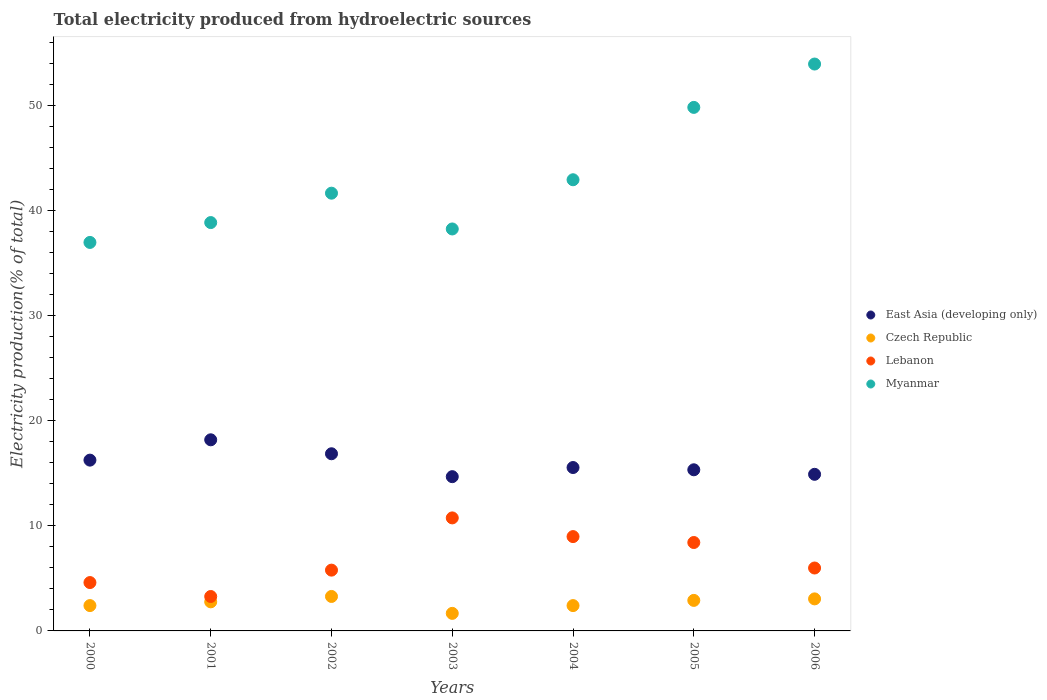What is the total electricity produced in Czech Republic in 2003?
Ensure brevity in your answer.  1.67. Across all years, what is the maximum total electricity produced in Lebanon?
Keep it short and to the point. 10.75. Across all years, what is the minimum total electricity produced in Lebanon?
Offer a very short reply. 3.28. In which year was the total electricity produced in Czech Republic maximum?
Your response must be concise. 2002. In which year was the total electricity produced in Czech Republic minimum?
Offer a very short reply. 2003. What is the total total electricity produced in Czech Republic in the graph?
Your answer should be compact. 18.49. What is the difference between the total electricity produced in Lebanon in 2001 and that in 2003?
Your answer should be compact. -7.48. What is the difference between the total electricity produced in Czech Republic in 2005 and the total electricity produced in Myanmar in 2000?
Offer a very short reply. -34.06. What is the average total electricity produced in Lebanon per year?
Ensure brevity in your answer.  6.83. In the year 2003, what is the difference between the total electricity produced in Czech Republic and total electricity produced in Lebanon?
Provide a short and direct response. -9.08. What is the ratio of the total electricity produced in Myanmar in 2003 to that in 2005?
Offer a very short reply. 0.77. What is the difference between the highest and the second highest total electricity produced in East Asia (developing only)?
Your answer should be very brief. 1.33. What is the difference between the highest and the lowest total electricity produced in Myanmar?
Your answer should be very brief. 16.97. In how many years, is the total electricity produced in Myanmar greater than the average total electricity produced in Myanmar taken over all years?
Make the answer very short. 2. Is it the case that in every year, the sum of the total electricity produced in Lebanon and total electricity produced in East Asia (developing only)  is greater than the sum of total electricity produced in Myanmar and total electricity produced in Czech Republic?
Make the answer very short. Yes. Does the total electricity produced in East Asia (developing only) monotonically increase over the years?
Provide a succinct answer. No. How many years are there in the graph?
Your answer should be compact. 7. Are the values on the major ticks of Y-axis written in scientific E-notation?
Offer a terse response. No. Does the graph contain any zero values?
Your answer should be compact. No. Where does the legend appear in the graph?
Keep it short and to the point. Center right. How are the legend labels stacked?
Your answer should be very brief. Vertical. What is the title of the graph?
Offer a very short reply. Total electricity produced from hydroelectric sources. What is the label or title of the Y-axis?
Your answer should be compact. Electricity production(% of total). What is the Electricity production(% of total) of East Asia (developing only) in 2000?
Keep it short and to the point. 16.25. What is the Electricity production(% of total) of Czech Republic in 2000?
Ensure brevity in your answer.  2.41. What is the Electricity production(% of total) of Lebanon in 2000?
Give a very brief answer. 4.6. What is the Electricity production(% of total) in Myanmar in 2000?
Keep it short and to the point. 36.97. What is the Electricity production(% of total) of East Asia (developing only) in 2001?
Provide a short and direct response. 18.19. What is the Electricity production(% of total) in Czech Republic in 2001?
Offer a terse response. 2.77. What is the Electricity production(% of total) of Lebanon in 2001?
Provide a succinct answer. 3.28. What is the Electricity production(% of total) in Myanmar in 2001?
Ensure brevity in your answer.  38.86. What is the Electricity production(% of total) of East Asia (developing only) in 2002?
Provide a succinct answer. 16.86. What is the Electricity production(% of total) of Czech Republic in 2002?
Offer a terse response. 3.28. What is the Electricity production(% of total) in Lebanon in 2002?
Your answer should be compact. 5.78. What is the Electricity production(% of total) of Myanmar in 2002?
Your answer should be compact. 41.65. What is the Electricity production(% of total) in East Asia (developing only) in 2003?
Provide a short and direct response. 14.68. What is the Electricity production(% of total) of Czech Republic in 2003?
Give a very brief answer. 1.67. What is the Electricity production(% of total) in Lebanon in 2003?
Your response must be concise. 10.75. What is the Electricity production(% of total) in Myanmar in 2003?
Your answer should be compact. 38.25. What is the Electricity production(% of total) in East Asia (developing only) in 2004?
Keep it short and to the point. 15.55. What is the Electricity production(% of total) of Czech Republic in 2004?
Keep it short and to the point. 2.41. What is the Electricity production(% of total) in Lebanon in 2004?
Provide a succinct answer. 8.98. What is the Electricity production(% of total) in Myanmar in 2004?
Offer a very short reply. 42.93. What is the Electricity production(% of total) of East Asia (developing only) in 2005?
Your response must be concise. 15.33. What is the Electricity production(% of total) of Czech Republic in 2005?
Your answer should be very brief. 2.9. What is the Electricity production(% of total) in Lebanon in 2005?
Your answer should be very brief. 8.41. What is the Electricity production(% of total) of Myanmar in 2005?
Your response must be concise. 49.82. What is the Electricity production(% of total) in East Asia (developing only) in 2006?
Offer a terse response. 14.9. What is the Electricity production(% of total) of Czech Republic in 2006?
Offer a very short reply. 3.05. What is the Electricity production(% of total) of Lebanon in 2006?
Your response must be concise. 5.99. What is the Electricity production(% of total) in Myanmar in 2006?
Your answer should be compact. 53.94. Across all years, what is the maximum Electricity production(% of total) in East Asia (developing only)?
Give a very brief answer. 18.19. Across all years, what is the maximum Electricity production(% of total) of Czech Republic?
Make the answer very short. 3.28. Across all years, what is the maximum Electricity production(% of total) of Lebanon?
Your answer should be compact. 10.75. Across all years, what is the maximum Electricity production(% of total) of Myanmar?
Keep it short and to the point. 53.94. Across all years, what is the minimum Electricity production(% of total) of East Asia (developing only)?
Offer a terse response. 14.68. Across all years, what is the minimum Electricity production(% of total) in Czech Republic?
Your answer should be very brief. 1.67. Across all years, what is the minimum Electricity production(% of total) of Lebanon?
Your answer should be compact. 3.28. Across all years, what is the minimum Electricity production(% of total) in Myanmar?
Your answer should be compact. 36.97. What is the total Electricity production(% of total) in East Asia (developing only) in the graph?
Your response must be concise. 111.76. What is the total Electricity production(% of total) in Czech Republic in the graph?
Provide a succinct answer. 18.49. What is the total Electricity production(% of total) in Lebanon in the graph?
Offer a terse response. 47.79. What is the total Electricity production(% of total) in Myanmar in the graph?
Provide a short and direct response. 302.42. What is the difference between the Electricity production(% of total) of East Asia (developing only) in 2000 and that in 2001?
Provide a short and direct response. -1.93. What is the difference between the Electricity production(% of total) of Czech Republic in 2000 and that in 2001?
Offer a very short reply. -0.36. What is the difference between the Electricity production(% of total) of Lebanon in 2000 and that in 2001?
Make the answer very short. 1.33. What is the difference between the Electricity production(% of total) in Myanmar in 2000 and that in 2001?
Make the answer very short. -1.89. What is the difference between the Electricity production(% of total) in East Asia (developing only) in 2000 and that in 2002?
Your answer should be very brief. -0.61. What is the difference between the Electricity production(% of total) in Czech Republic in 2000 and that in 2002?
Offer a terse response. -0.87. What is the difference between the Electricity production(% of total) of Lebanon in 2000 and that in 2002?
Your response must be concise. -1.18. What is the difference between the Electricity production(% of total) in Myanmar in 2000 and that in 2002?
Offer a very short reply. -4.69. What is the difference between the Electricity production(% of total) of East Asia (developing only) in 2000 and that in 2003?
Offer a very short reply. 1.57. What is the difference between the Electricity production(% of total) in Czech Republic in 2000 and that in 2003?
Offer a very short reply. 0.74. What is the difference between the Electricity production(% of total) of Lebanon in 2000 and that in 2003?
Make the answer very short. -6.15. What is the difference between the Electricity production(% of total) of Myanmar in 2000 and that in 2003?
Your response must be concise. -1.28. What is the difference between the Electricity production(% of total) in East Asia (developing only) in 2000 and that in 2004?
Offer a very short reply. 0.7. What is the difference between the Electricity production(% of total) in Czech Republic in 2000 and that in 2004?
Make the answer very short. 0. What is the difference between the Electricity production(% of total) in Lebanon in 2000 and that in 2004?
Keep it short and to the point. -4.37. What is the difference between the Electricity production(% of total) of Myanmar in 2000 and that in 2004?
Give a very brief answer. -5.96. What is the difference between the Electricity production(% of total) of East Asia (developing only) in 2000 and that in 2005?
Make the answer very short. 0.92. What is the difference between the Electricity production(% of total) in Czech Republic in 2000 and that in 2005?
Keep it short and to the point. -0.49. What is the difference between the Electricity production(% of total) of Lebanon in 2000 and that in 2005?
Ensure brevity in your answer.  -3.81. What is the difference between the Electricity production(% of total) of Myanmar in 2000 and that in 2005?
Ensure brevity in your answer.  -12.85. What is the difference between the Electricity production(% of total) in East Asia (developing only) in 2000 and that in 2006?
Your answer should be very brief. 1.35. What is the difference between the Electricity production(% of total) in Czech Republic in 2000 and that in 2006?
Offer a terse response. -0.64. What is the difference between the Electricity production(% of total) in Lebanon in 2000 and that in 2006?
Provide a succinct answer. -1.38. What is the difference between the Electricity production(% of total) of Myanmar in 2000 and that in 2006?
Provide a short and direct response. -16.97. What is the difference between the Electricity production(% of total) in East Asia (developing only) in 2001 and that in 2002?
Your response must be concise. 1.33. What is the difference between the Electricity production(% of total) of Czech Republic in 2001 and that in 2002?
Offer a very short reply. -0.51. What is the difference between the Electricity production(% of total) in Lebanon in 2001 and that in 2002?
Keep it short and to the point. -2.51. What is the difference between the Electricity production(% of total) in Myanmar in 2001 and that in 2002?
Make the answer very short. -2.8. What is the difference between the Electricity production(% of total) of East Asia (developing only) in 2001 and that in 2003?
Make the answer very short. 3.51. What is the difference between the Electricity production(% of total) in Czech Republic in 2001 and that in 2003?
Keep it short and to the point. 1.1. What is the difference between the Electricity production(% of total) of Lebanon in 2001 and that in 2003?
Ensure brevity in your answer.  -7.48. What is the difference between the Electricity production(% of total) of Myanmar in 2001 and that in 2003?
Offer a terse response. 0.61. What is the difference between the Electricity production(% of total) of East Asia (developing only) in 2001 and that in 2004?
Offer a terse response. 2.64. What is the difference between the Electricity production(% of total) of Czech Republic in 2001 and that in 2004?
Provide a short and direct response. 0.36. What is the difference between the Electricity production(% of total) of Lebanon in 2001 and that in 2004?
Keep it short and to the point. -5.7. What is the difference between the Electricity production(% of total) in Myanmar in 2001 and that in 2004?
Offer a very short reply. -4.07. What is the difference between the Electricity production(% of total) of East Asia (developing only) in 2001 and that in 2005?
Keep it short and to the point. 2.85. What is the difference between the Electricity production(% of total) of Czech Republic in 2001 and that in 2005?
Your answer should be very brief. -0.14. What is the difference between the Electricity production(% of total) of Lebanon in 2001 and that in 2005?
Offer a terse response. -5.14. What is the difference between the Electricity production(% of total) in Myanmar in 2001 and that in 2005?
Make the answer very short. -10.96. What is the difference between the Electricity production(% of total) in East Asia (developing only) in 2001 and that in 2006?
Offer a very short reply. 3.28. What is the difference between the Electricity production(% of total) of Czech Republic in 2001 and that in 2006?
Offer a terse response. -0.28. What is the difference between the Electricity production(% of total) in Lebanon in 2001 and that in 2006?
Keep it short and to the point. -2.71. What is the difference between the Electricity production(% of total) in Myanmar in 2001 and that in 2006?
Offer a very short reply. -15.09. What is the difference between the Electricity production(% of total) of East Asia (developing only) in 2002 and that in 2003?
Your answer should be very brief. 2.18. What is the difference between the Electricity production(% of total) of Czech Republic in 2002 and that in 2003?
Keep it short and to the point. 1.61. What is the difference between the Electricity production(% of total) in Lebanon in 2002 and that in 2003?
Offer a terse response. -4.97. What is the difference between the Electricity production(% of total) in Myanmar in 2002 and that in 2003?
Your answer should be compact. 3.4. What is the difference between the Electricity production(% of total) in East Asia (developing only) in 2002 and that in 2004?
Offer a very short reply. 1.31. What is the difference between the Electricity production(% of total) of Czech Republic in 2002 and that in 2004?
Ensure brevity in your answer.  0.87. What is the difference between the Electricity production(% of total) of Lebanon in 2002 and that in 2004?
Offer a terse response. -3.19. What is the difference between the Electricity production(% of total) in Myanmar in 2002 and that in 2004?
Offer a terse response. -1.28. What is the difference between the Electricity production(% of total) in East Asia (developing only) in 2002 and that in 2005?
Ensure brevity in your answer.  1.53. What is the difference between the Electricity production(% of total) in Czech Republic in 2002 and that in 2005?
Ensure brevity in your answer.  0.37. What is the difference between the Electricity production(% of total) of Lebanon in 2002 and that in 2005?
Offer a very short reply. -2.63. What is the difference between the Electricity production(% of total) of Myanmar in 2002 and that in 2005?
Provide a short and direct response. -8.16. What is the difference between the Electricity production(% of total) of East Asia (developing only) in 2002 and that in 2006?
Give a very brief answer. 1.96. What is the difference between the Electricity production(% of total) of Czech Republic in 2002 and that in 2006?
Offer a terse response. 0.23. What is the difference between the Electricity production(% of total) in Lebanon in 2002 and that in 2006?
Offer a terse response. -0.2. What is the difference between the Electricity production(% of total) in Myanmar in 2002 and that in 2006?
Your answer should be very brief. -12.29. What is the difference between the Electricity production(% of total) of East Asia (developing only) in 2003 and that in 2004?
Make the answer very short. -0.87. What is the difference between the Electricity production(% of total) of Czech Republic in 2003 and that in 2004?
Your answer should be compact. -0.74. What is the difference between the Electricity production(% of total) in Lebanon in 2003 and that in 2004?
Offer a terse response. 1.78. What is the difference between the Electricity production(% of total) in Myanmar in 2003 and that in 2004?
Your answer should be very brief. -4.68. What is the difference between the Electricity production(% of total) in East Asia (developing only) in 2003 and that in 2005?
Keep it short and to the point. -0.65. What is the difference between the Electricity production(% of total) in Czech Republic in 2003 and that in 2005?
Provide a short and direct response. -1.23. What is the difference between the Electricity production(% of total) in Lebanon in 2003 and that in 2005?
Your answer should be compact. 2.34. What is the difference between the Electricity production(% of total) in Myanmar in 2003 and that in 2005?
Offer a terse response. -11.57. What is the difference between the Electricity production(% of total) in East Asia (developing only) in 2003 and that in 2006?
Provide a succinct answer. -0.22. What is the difference between the Electricity production(% of total) of Czech Republic in 2003 and that in 2006?
Keep it short and to the point. -1.38. What is the difference between the Electricity production(% of total) in Lebanon in 2003 and that in 2006?
Provide a succinct answer. 4.77. What is the difference between the Electricity production(% of total) of Myanmar in 2003 and that in 2006?
Give a very brief answer. -15.69. What is the difference between the Electricity production(% of total) in East Asia (developing only) in 2004 and that in 2005?
Provide a succinct answer. 0.22. What is the difference between the Electricity production(% of total) in Czech Republic in 2004 and that in 2005?
Provide a succinct answer. -0.5. What is the difference between the Electricity production(% of total) of Lebanon in 2004 and that in 2005?
Give a very brief answer. 0.56. What is the difference between the Electricity production(% of total) in Myanmar in 2004 and that in 2005?
Provide a short and direct response. -6.89. What is the difference between the Electricity production(% of total) of East Asia (developing only) in 2004 and that in 2006?
Provide a short and direct response. 0.65. What is the difference between the Electricity production(% of total) of Czech Republic in 2004 and that in 2006?
Offer a very short reply. -0.64. What is the difference between the Electricity production(% of total) in Lebanon in 2004 and that in 2006?
Ensure brevity in your answer.  2.99. What is the difference between the Electricity production(% of total) of Myanmar in 2004 and that in 2006?
Your answer should be compact. -11.01. What is the difference between the Electricity production(% of total) of East Asia (developing only) in 2005 and that in 2006?
Provide a succinct answer. 0.43. What is the difference between the Electricity production(% of total) in Czech Republic in 2005 and that in 2006?
Offer a terse response. -0.14. What is the difference between the Electricity production(% of total) in Lebanon in 2005 and that in 2006?
Offer a very short reply. 2.43. What is the difference between the Electricity production(% of total) of Myanmar in 2005 and that in 2006?
Your answer should be very brief. -4.13. What is the difference between the Electricity production(% of total) of East Asia (developing only) in 2000 and the Electricity production(% of total) of Czech Republic in 2001?
Offer a terse response. 13.49. What is the difference between the Electricity production(% of total) of East Asia (developing only) in 2000 and the Electricity production(% of total) of Lebanon in 2001?
Provide a succinct answer. 12.98. What is the difference between the Electricity production(% of total) of East Asia (developing only) in 2000 and the Electricity production(% of total) of Myanmar in 2001?
Ensure brevity in your answer.  -22.6. What is the difference between the Electricity production(% of total) of Czech Republic in 2000 and the Electricity production(% of total) of Lebanon in 2001?
Your response must be concise. -0.86. What is the difference between the Electricity production(% of total) in Czech Republic in 2000 and the Electricity production(% of total) in Myanmar in 2001?
Give a very brief answer. -36.45. What is the difference between the Electricity production(% of total) of Lebanon in 2000 and the Electricity production(% of total) of Myanmar in 2001?
Offer a terse response. -34.26. What is the difference between the Electricity production(% of total) in East Asia (developing only) in 2000 and the Electricity production(% of total) in Czech Republic in 2002?
Keep it short and to the point. 12.97. What is the difference between the Electricity production(% of total) of East Asia (developing only) in 2000 and the Electricity production(% of total) of Lebanon in 2002?
Offer a terse response. 10.47. What is the difference between the Electricity production(% of total) of East Asia (developing only) in 2000 and the Electricity production(% of total) of Myanmar in 2002?
Keep it short and to the point. -25.4. What is the difference between the Electricity production(% of total) in Czech Republic in 2000 and the Electricity production(% of total) in Lebanon in 2002?
Your answer should be very brief. -3.37. What is the difference between the Electricity production(% of total) of Czech Republic in 2000 and the Electricity production(% of total) of Myanmar in 2002?
Your response must be concise. -39.24. What is the difference between the Electricity production(% of total) in Lebanon in 2000 and the Electricity production(% of total) in Myanmar in 2002?
Give a very brief answer. -37.05. What is the difference between the Electricity production(% of total) of East Asia (developing only) in 2000 and the Electricity production(% of total) of Czech Republic in 2003?
Offer a very short reply. 14.58. What is the difference between the Electricity production(% of total) of East Asia (developing only) in 2000 and the Electricity production(% of total) of Lebanon in 2003?
Keep it short and to the point. 5.5. What is the difference between the Electricity production(% of total) of East Asia (developing only) in 2000 and the Electricity production(% of total) of Myanmar in 2003?
Your response must be concise. -22. What is the difference between the Electricity production(% of total) in Czech Republic in 2000 and the Electricity production(% of total) in Lebanon in 2003?
Your answer should be very brief. -8.34. What is the difference between the Electricity production(% of total) in Czech Republic in 2000 and the Electricity production(% of total) in Myanmar in 2003?
Your response must be concise. -35.84. What is the difference between the Electricity production(% of total) in Lebanon in 2000 and the Electricity production(% of total) in Myanmar in 2003?
Offer a very short reply. -33.65. What is the difference between the Electricity production(% of total) in East Asia (developing only) in 2000 and the Electricity production(% of total) in Czech Republic in 2004?
Make the answer very short. 13.84. What is the difference between the Electricity production(% of total) in East Asia (developing only) in 2000 and the Electricity production(% of total) in Lebanon in 2004?
Your answer should be compact. 7.28. What is the difference between the Electricity production(% of total) of East Asia (developing only) in 2000 and the Electricity production(% of total) of Myanmar in 2004?
Your answer should be compact. -26.68. What is the difference between the Electricity production(% of total) in Czech Republic in 2000 and the Electricity production(% of total) in Lebanon in 2004?
Provide a succinct answer. -6.56. What is the difference between the Electricity production(% of total) in Czech Republic in 2000 and the Electricity production(% of total) in Myanmar in 2004?
Ensure brevity in your answer.  -40.52. What is the difference between the Electricity production(% of total) in Lebanon in 2000 and the Electricity production(% of total) in Myanmar in 2004?
Ensure brevity in your answer.  -38.33. What is the difference between the Electricity production(% of total) of East Asia (developing only) in 2000 and the Electricity production(% of total) of Czech Republic in 2005?
Your response must be concise. 13.35. What is the difference between the Electricity production(% of total) in East Asia (developing only) in 2000 and the Electricity production(% of total) in Lebanon in 2005?
Make the answer very short. 7.84. What is the difference between the Electricity production(% of total) of East Asia (developing only) in 2000 and the Electricity production(% of total) of Myanmar in 2005?
Give a very brief answer. -33.57. What is the difference between the Electricity production(% of total) in Czech Republic in 2000 and the Electricity production(% of total) in Lebanon in 2005?
Give a very brief answer. -6. What is the difference between the Electricity production(% of total) in Czech Republic in 2000 and the Electricity production(% of total) in Myanmar in 2005?
Make the answer very short. -47.41. What is the difference between the Electricity production(% of total) of Lebanon in 2000 and the Electricity production(% of total) of Myanmar in 2005?
Provide a short and direct response. -45.22. What is the difference between the Electricity production(% of total) in East Asia (developing only) in 2000 and the Electricity production(% of total) in Czech Republic in 2006?
Your answer should be very brief. 13.2. What is the difference between the Electricity production(% of total) of East Asia (developing only) in 2000 and the Electricity production(% of total) of Lebanon in 2006?
Your answer should be very brief. 10.27. What is the difference between the Electricity production(% of total) of East Asia (developing only) in 2000 and the Electricity production(% of total) of Myanmar in 2006?
Give a very brief answer. -37.69. What is the difference between the Electricity production(% of total) in Czech Republic in 2000 and the Electricity production(% of total) in Lebanon in 2006?
Your response must be concise. -3.58. What is the difference between the Electricity production(% of total) in Czech Republic in 2000 and the Electricity production(% of total) in Myanmar in 2006?
Offer a very short reply. -51.53. What is the difference between the Electricity production(% of total) in Lebanon in 2000 and the Electricity production(% of total) in Myanmar in 2006?
Provide a short and direct response. -49.34. What is the difference between the Electricity production(% of total) in East Asia (developing only) in 2001 and the Electricity production(% of total) in Czech Republic in 2002?
Offer a very short reply. 14.91. What is the difference between the Electricity production(% of total) of East Asia (developing only) in 2001 and the Electricity production(% of total) of Lebanon in 2002?
Provide a short and direct response. 12.4. What is the difference between the Electricity production(% of total) of East Asia (developing only) in 2001 and the Electricity production(% of total) of Myanmar in 2002?
Offer a terse response. -23.47. What is the difference between the Electricity production(% of total) of Czech Republic in 2001 and the Electricity production(% of total) of Lebanon in 2002?
Your answer should be compact. -3.02. What is the difference between the Electricity production(% of total) in Czech Republic in 2001 and the Electricity production(% of total) in Myanmar in 2002?
Provide a short and direct response. -38.89. What is the difference between the Electricity production(% of total) in Lebanon in 2001 and the Electricity production(% of total) in Myanmar in 2002?
Your answer should be compact. -38.38. What is the difference between the Electricity production(% of total) of East Asia (developing only) in 2001 and the Electricity production(% of total) of Czech Republic in 2003?
Ensure brevity in your answer.  16.52. What is the difference between the Electricity production(% of total) in East Asia (developing only) in 2001 and the Electricity production(% of total) in Lebanon in 2003?
Your answer should be compact. 7.43. What is the difference between the Electricity production(% of total) of East Asia (developing only) in 2001 and the Electricity production(% of total) of Myanmar in 2003?
Provide a short and direct response. -20.06. What is the difference between the Electricity production(% of total) in Czech Republic in 2001 and the Electricity production(% of total) in Lebanon in 2003?
Your answer should be compact. -7.99. What is the difference between the Electricity production(% of total) of Czech Republic in 2001 and the Electricity production(% of total) of Myanmar in 2003?
Your response must be concise. -35.48. What is the difference between the Electricity production(% of total) in Lebanon in 2001 and the Electricity production(% of total) in Myanmar in 2003?
Offer a terse response. -34.97. What is the difference between the Electricity production(% of total) of East Asia (developing only) in 2001 and the Electricity production(% of total) of Czech Republic in 2004?
Provide a succinct answer. 15.78. What is the difference between the Electricity production(% of total) in East Asia (developing only) in 2001 and the Electricity production(% of total) in Lebanon in 2004?
Give a very brief answer. 9.21. What is the difference between the Electricity production(% of total) in East Asia (developing only) in 2001 and the Electricity production(% of total) in Myanmar in 2004?
Provide a succinct answer. -24.74. What is the difference between the Electricity production(% of total) in Czech Republic in 2001 and the Electricity production(% of total) in Lebanon in 2004?
Make the answer very short. -6.21. What is the difference between the Electricity production(% of total) of Czech Republic in 2001 and the Electricity production(% of total) of Myanmar in 2004?
Provide a short and direct response. -40.16. What is the difference between the Electricity production(% of total) in Lebanon in 2001 and the Electricity production(% of total) in Myanmar in 2004?
Your response must be concise. -39.66. What is the difference between the Electricity production(% of total) in East Asia (developing only) in 2001 and the Electricity production(% of total) in Czech Republic in 2005?
Ensure brevity in your answer.  15.28. What is the difference between the Electricity production(% of total) of East Asia (developing only) in 2001 and the Electricity production(% of total) of Lebanon in 2005?
Provide a succinct answer. 9.77. What is the difference between the Electricity production(% of total) of East Asia (developing only) in 2001 and the Electricity production(% of total) of Myanmar in 2005?
Give a very brief answer. -31.63. What is the difference between the Electricity production(% of total) of Czech Republic in 2001 and the Electricity production(% of total) of Lebanon in 2005?
Provide a succinct answer. -5.65. What is the difference between the Electricity production(% of total) in Czech Republic in 2001 and the Electricity production(% of total) in Myanmar in 2005?
Offer a very short reply. -47.05. What is the difference between the Electricity production(% of total) in Lebanon in 2001 and the Electricity production(% of total) in Myanmar in 2005?
Make the answer very short. -46.54. What is the difference between the Electricity production(% of total) of East Asia (developing only) in 2001 and the Electricity production(% of total) of Czech Republic in 2006?
Give a very brief answer. 15.14. What is the difference between the Electricity production(% of total) of East Asia (developing only) in 2001 and the Electricity production(% of total) of Lebanon in 2006?
Your response must be concise. 12.2. What is the difference between the Electricity production(% of total) of East Asia (developing only) in 2001 and the Electricity production(% of total) of Myanmar in 2006?
Offer a terse response. -35.76. What is the difference between the Electricity production(% of total) of Czech Republic in 2001 and the Electricity production(% of total) of Lebanon in 2006?
Give a very brief answer. -3.22. What is the difference between the Electricity production(% of total) of Czech Republic in 2001 and the Electricity production(% of total) of Myanmar in 2006?
Keep it short and to the point. -51.18. What is the difference between the Electricity production(% of total) of Lebanon in 2001 and the Electricity production(% of total) of Myanmar in 2006?
Offer a terse response. -50.67. What is the difference between the Electricity production(% of total) of East Asia (developing only) in 2002 and the Electricity production(% of total) of Czech Republic in 2003?
Your response must be concise. 15.19. What is the difference between the Electricity production(% of total) of East Asia (developing only) in 2002 and the Electricity production(% of total) of Lebanon in 2003?
Offer a terse response. 6.1. What is the difference between the Electricity production(% of total) of East Asia (developing only) in 2002 and the Electricity production(% of total) of Myanmar in 2003?
Your answer should be compact. -21.39. What is the difference between the Electricity production(% of total) of Czech Republic in 2002 and the Electricity production(% of total) of Lebanon in 2003?
Provide a succinct answer. -7.48. What is the difference between the Electricity production(% of total) in Czech Republic in 2002 and the Electricity production(% of total) in Myanmar in 2003?
Offer a terse response. -34.97. What is the difference between the Electricity production(% of total) of Lebanon in 2002 and the Electricity production(% of total) of Myanmar in 2003?
Ensure brevity in your answer.  -32.46. What is the difference between the Electricity production(% of total) in East Asia (developing only) in 2002 and the Electricity production(% of total) in Czech Republic in 2004?
Offer a terse response. 14.45. What is the difference between the Electricity production(% of total) in East Asia (developing only) in 2002 and the Electricity production(% of total) in Lebanon in 2004?
Offer a terse response. 7.88. What is the difference between the Electricity production(% of total) in East Asia (developing only) in 2002 and the Electricity production(% of total) in Myanmar in 2004?
Make the answer very short. -26.07. What is the difference between the Electricity production(% of total) in Czech Republic in 2002 and the Electricity production(% of total) in Lebanon in 2004?
Provide a short and direct response. -5.7. What is the difference between the Electricity production(% of total) in Czech Republic in 2002 and the Electricity production(% of total) in Myanmar in 2004?
Your response must be concise. -39.65. What is the difference between the Electricity production(% of total) in Lebanon in 2002 and the Electricity production(% of total) in Myanmar in 2004?
Your answer should be very brief. -37.15. What is the difference between the Electricity production(% of total) of East Asia (developing only) in 2002 and the Electricity production(% of total) of Czech Republic in 2005?
Your answer should be compact. 13.95. What is the difference between the Electricity production(% of total) in East Asia (developing only) in 2002 and the Electricity production(% of total) in Lebanon in 2005?
Your response must be concise. 8.44. What is the difference between the Electricity production(% of total) in East Asia (developing only) in 2002 and the Electricity production(% of total) in Myanmar in 2005?
Offer a terse response. -32.96. What is the difference between the Electricity production(% of total) in Czech Republic in 2002 and the Electricity production(% of total) in Lebanon in 2005?
Your answer should be compact. -5.13. What is the difference between the Electricity production(% of total) in Czech Republic in 2002 and the Electricity production(% of total) in Myanmar in 2005?
Offer a very short reply. -46.54. What is the difference between the Electricity production(% of total) of Lebanon in 2002 and the Electricity production(% of total) of Myanmar in 2005?
Give a very brief answer. -44.03. What is the difference between the Electricity production(% of total) in East Asia (developing only) in 2002 and the Electricity production(% of total) in Czech Republic in 2006?
Give a very brief answer. 13.81. What is the difference between the Electricity production(% of total) in East Asia (developing only) in 2002 and the Electricity production(% of total) in Lebanon in 2006?
Your response must be concise. 10.87. What is the difference between the Electricity production(% of total) in East Asia (developing only) in 2002 and the Electricity production(% of total) in Myanmar in 2006?
Your answer should be very brief. -37.08. What is the difference between the Electricity production(% of total) in Czech Republic in 2002 and the Electricity production(% of total) in Lebanon in 2006?
Keep it short and to the point. -2.71. What is the difference between the Electricity production(% of total) of Czech Republic in 2002 and the Electricity production(% of total) of Myanmar in 2006?
Keep it short and to the point. -50.66. What is the difference between the Electricity production(% of total) in Lebanon in 2002 and the Electricity production(% of total) in Myanmar in 2006?
Give a very brief answer. -48.16. What is the difference between the Electricity production(% of total) of East Asia (developing only) in 2003 and the Electricity production(% of total) of Czech Republic in 2004?
Ensure brevity in your answer.  12.27. What is the difference between the Electricity production(% of total) of East Asia (developing only) in 2003 and the Electricity production(% of total) of Lebanon in 2004?
Make the answer very short. 5.7. What is the difference between the Electricity production(% of total) in East Asia (developing only) in 2003 and the Electricity production(% of total) in Myanmar in 2004?
Give a very brief answer. -28.25. What is the difference between the Electricity production(% of total) in Czech Republic in 2003 and the Electricity production(% of total) in Lebanon in 2004?
Your answer should be compact. -7.31. What is the difference between the Electricity production(% of total) of Czech Republic in 2003 and the Electricity production(% of total) of Myanmar in 2004?
Offer a very short reply. -41.26. What is the difference between the Electricity production(% of total) of Lebanon in 2003 and the Electricity production(% of total) of Myanmar in 2004?
Provide a succinct answer. -32.18. What is the difference between the Electricity production(% of total) of East Asia (developing only) in 2003 and the Electricity production(% of total) of Czech Republic in 2005?
Your answer should be very brief. 11.77. What is the difference between the Electricity production(% of total) of East Asia (developing only) in 2003 and the Electricity production(% of total) of Lebanon in 2005?
Keep it short and to the point. 6.27. What is the difference between the Electricity production(% of total) in East Asia (developing only) in 2003 and the Electricity production(% of total) in Myanmar in 2005?
Provide a succinct answer. -35.14. What is the difference between the Electricity production(% of total) of Czech Republic in 2003 and the Electricity production(% of total) of Lebanon in 2005?
Give a very brief answer. -6.74. What is the difference between the Electricity production(% of total) of Czech Republic in 2003 and the Electricity production(% of total) of Myanmar in 2005?
Your answer should be compact. -48.15. What is the difference between the Electricity production(% of total) in Lebanon in 2003 and the Electricity production(% of total) in Myanmar in 2005?
Your response must be concise. -39.06. What is the difference between the Electricity production(% of total) in East Asia (developing only) in 2003 and the Electricity production(% of total) in Czech Republic in 2006?
Give a very brief answer. 11.63. What is the difference between the Electricity production(% of total) in East Asia (developing only) in 2003 and the Electricity production(% of total) in Lebanon in 2006?
Your answer should be very brief. 8.69. What is the difference between the Electricity production(% of total) of East Asia (developing only) in 2003 and the Electricity production(% of total) of Myanmar in 2006?
Give a very brief answer. -39.26. What is the difference between the Electricity production(% of total) in Czech Republic in 2003 and the Electricity production(% of total) in Lebanon in 2006?
Offer a very short reply. -4.32. What is the difference between the Electricity production(% of total) of Czech Republic in 2003 and the Electricity production(% of total) of Myanmar in 2006?
Your answer should be compact. -52.27. What is the difference between the Electricity production(% of total) in Lebanon in 2003 and the Electricity production(% of total) in Myanmar in 2006?
Your answer should be very brief. -43.19. What is the difference between the Electricity production(% of total) of East Asia (developing only) in 2004 and the Electricity production(% of total) of Czech Republic in 2005?
Provide a succinct answer. 12.64. What is the difference between the Electricity production(% of total) in East Asia (developing only) in 2004 and the Electricity production(% of total) in Lebanon in 2005?
Your answer should be compact. 7.13. What is the difference between the Electricity production(% of total) in East Asia (developing only) in 2004 and the Electricity production(% of total) in Myanmar in 2005?
Provide a short and direct response. -34.27. What is the difference between the Electricity production(% of total) of Czech Republic in 2004 and the Electricity production(% of total) of Lebanon in 2005?
Keep it short and to the point. -6. What is the difference between the Electricity production(% of total) in Czech Republic in 2004 and the Electricity production(% of total) in Myanmar in 2005?
Keep it short and to the point. -47.41. What is the difference between the Electricity production(% of total) in Lebanon in 2004 and the Electricity production(% of total) in Myanmar in 2005?
Your answer should be very brief. -40.84. What is the difference between the Electricity production(% of total) in East Asia (developing only) in 2004 and the Electricity production(% of total) in Czech Republic in 2006?
Your answer should be compact. 12.5. What is the difference between the Electricity production(% of total) in East Asia (developing only) in 2004 and the Electricity production(% of total) in Lebanon in 2006?
Provide a succinct answer. 9.56. What is the difference between the Electricity production(% of total) of East Asia (developing only) in 2004 and the Electricity production(% of total) of Myanmar in 2006?
Keep it short and to the point. -38.39. What is the difference between the Electricity production(% of total) of Czech Republic in 2004 and the Electricity production(% of total) of Lebanon in 2006?
Provide a succinct answer. -3.58. What is the difference between the Electricity production(% of total) in Czech Republic in 2004 and the Electricity production(% of total) in Myanmar in 2006?
Give a very brief answer. -51.53. What is the difference between the Electricity production(% of total) of Lebanon in 2004 and the Electricity production(% of total) of Myanmar in 2006?
Your response must be concise. -44.97. What is the difference between the Electricity production(% of total) in East Asia (developing only) in 2005 and the Electricity production(% of total) in Czech Republic in 2006?
Offer a very short reply. 12.28. What is the difference between the Electricity production(% of total) in East Asia (developing only) in 2005 and the Electricity production(% of total) in Lebanon in 2006?
Provide a short and direct response. 9.35. What is the difference between the Electricity production(% of total) of East Asia (developing only) in 2005 and the Electricity production(% of total) of Myanmar in 2006?
Provide a succinct answer. -38.61. What is the difference between the Electricity production(% of total) of Czech Republic in 2005 and the Electricity production(% of total) of Lebanon in 2006?
Offer a very short reply. -3.08. What is the difference between the Electricity production(% of total) of Czech Republic in 2005 and the Electricity production(% of total) of Myanmar in 2006?
Offer a terse response. -51.04. What is the difference between the Electricity production(% of total) in Lebanon in 2005 and the Electricity production(% of total) in Myanmar in 2006?
Offer a terse response. -45.53. What is the average Electricity production(% of total) in East Asia (developing only) per year?
Make the answer very short. 15.97. What is the average Electricity production(% of total) in Czech Republic per year?
Ensure brevity in your answer.  2.64. What is the average Electricity production(% of total) in Lebanon per year?
Give a very brief answer. 6.83. What is the average Electricity production(% of total) of Myanmar per year?
Your answer should be very brief. 43.2. In the year 2000, what is the difference between the Electricity production(% of total) in East Asia (developing only) and Electricity production(% of total) in Czech Republic?
Offer a terse response. 13.84. In the year 2000, what is the difference between the Electricity production(% of total) in East Asia (developing only) and Electricity production(% of total) in Lebanon?
Your answer should be compact. 11.65. In the year 2000, what is the difference between the Electricity production(% of total) in East Asia (developing only) and Electricity production(% of total) in Myanmar?
Make the answer very short. -20.72. In the year 2000, what is the difference between the Electricity production(% of total) in Czech Republic and Electricity production(% of total) in Lebanon?
Give a very brief answer. -2.19. In the year 2000, what is the difference between the Electricity production(% of total) in Czech Republic and Electricity production(% of total) in Myanmar?
Offer a very short reply. -34.56. In the year 2000, what is the difference between the Electricity production(% of total) in Lebanon and Electricity production(% of total) in Myanmar?
Provide a succinct answer. -32.37. In the year 2001, what is the difference between the Electricity production(% of total) of East Asia (developing only) and Electricity production(% of total) of Czech Republic?
Provide a short and direct response. 15.42. In the year 2001, what is the difference between the Electricity production(% of total) in East Asia (developing only) and Electricity production(% of total) in Lebanon?
Keep it short and to the point. 14.91. In the year 2001, what is the difference between the Electricity production(% of total) in East Asia (developing only) and Electricity production(% of total) in Myanmar?
Your answer should be very brief. -20.67. In the year 2001, what is the difference between the Electricity production(% of total) in Czech Republic and Electricity production(% of total) in Lebanon?
Provide a succinct answer. -0.51. In the year 2001, what is the difference between the Electricity production(% of total) of Czech Republic and Electricity production(% of total) of Myanmar?
Your response must be concise. -36.09. In the year 2001, what is the difference between the Electricity production(% of total) of Lebanon and Electricity production(% of total) of Myanmar?
Offer a very short reply. -35.58. In the year 2002, what is the difference between the Electricity production(% of total) of East Asia (developing only) and Electricity production(% of total) of Czech Republic?
Offer a terse response. 13.58. In the year 2002, what is the difference between the Electricity production(% of total) of East Asia (developing only) and Electricity production(% of total) of Lebanon?
Your answer should be very brief. 11.07. In the year 2002, what is the difference between the Electricity production(% of total) of East Asia (developing only) and Electricity production(% of total) of Myanmar?
Make the answer very short. -24.8. In the year 2002, what is the difference between the Electricity production(% of total) of Czech Republic and Electricity production(% of total) of Lebanon?
Ensure brevity in your answer.  -2.51. In the year 2002, what is the difference between the Electricity production(% of total) of Czech Republic and Electricity production(% of total) of Myanmar?
Your answer should be very brief. -38.37. In the year 2002, what is the difference between the Electricity production(% of total) of Lebanon and Electricity production(% of total) of Myanmar?
Provide a succinct answer. -35.87. In the year 2003, what is the difference between the Electricity production(% of total) in East Asia (developing only) and Electricity production(% of total) in Czech Republic?
Your answer should be very brief. 13.01. In the year 2003, what is the difference between the Electricity production(% of total) of East Asia (developing only) and Electricity production(% of total) of Lebanon?
Give a very brief answer. 3.92. In the year 2003, what is the difference between the Electricity production(% of total) in East Asia (developing only) and Electricity production(% of total) in Myanmar?
Offer a terse response. -23.57. In the year 2003, what is the difference between the Electricity production(% of total) of Czech Republic and Electricity production(% of total) of Lebanon?
Ensure brevity in your answer.  -9.08. In the year 2003, what is the difference between the Electricity production(% of total) in Czech Republic and Electricity production(% of total) in Myanmar?
Your response must be concise. -36.58. In the year 2003, what is the difference between the Electricity production(% of total) in Lebanon and Electricity production(% of total) in Myanmar?
Make the answer very short. -27.49. In the year 2004, what is the difference between the Electricity production(% of total) of East Asia (developing only) and Electricity production(% of total) of Czech Republic?
Your answer should be compact. 13.14. In the year 2004, what is the difference between the Electricity production(% of total) in East Asia (developing only) and Electricity production(% of total) in Lebanon?
Provide a short and direct response. 6.57. In the year 2004, what is the difference between the Electricity production(% of total) of East Asia (developing only) and Electricity production(% of total) of Myanmar?
Your response must be concise. -27.38. In the year 2004, what is the difference between the Electricity production(% of total) in Czech Republic and Electricity production(% of total) in Lebanon?
Your response must be concise. -6.57. In the year 2004, what is the difference between the Electricity production(% of total) in Czech Republic and Electricity production(% of total) in Myanmar?
Your response must be concise. -40.52. In the year 2004, what is the difference between the Electricity production(% of total) in Lebanon and Electricity production(% of total) in Myanmar?
Your answer should be very brief. -33.96. In the year 2005, what is the difference between the Electricity production(% of total) of East Asia (developing only) and Electricity production(% of total) of Czech Republic?
Keep it short and to the point. 12.43. In the year 2005, what is the difference between the Electricity production(% of total) of East Asia (developing only) and Electricity production(% of total) of Lebanon?
Ensure brevity in your answer.  6.92. In the year 2005, what is the difference between the Electricity production(% of total) of East Asia (developing only) and Electricity production(% of total) of Myanmar?
Your answer should be compact. -34.48. In the year 2005, what is the difference between the Electricity production(% of total) in Czech Republic and Electricity production(% of total) in Lebanon?
Ensure brevity in your answer.  -5.51. In the year 2005, what is the difference between the Electricity production(% of total) in Czech Republic and Electricity production(% of total) in Myanmar?
Provide a short and direct response. -46.91. In the year 2005, what is the difference between the Electricity production(% of total) of Lebanon and Electricity production(% of total) of Myanmar?
Give a very brief answer. -41.4. In the year 2006, what is the difference between the Electricity production(% of total) in East Asia (developing only) and Electricity production(% of total) in Czech Republic?
Your response must be concise. 11.85. In the year 2006, what is the difference between the Electricity production(% of total) of East Asia (developing only) and Electricity production(% of total) of Lebanon?
Give a very brief answer. 8.92. In the year 2006, what is the difference between the Electricity production(% of total) in East Asia (developing only) and Electricity production(% of total) in Myanmar?
Offer a terse response. -39.04. In the year 2006, what is the difference between the Electricity production(% of total) of Czech Republic and Electricity production(% of total) of Lebanon?
Provide a succinct answer. -2.94. In the year 2006, what is the difference between the Electricity production(% of total) in Czech Republic and Electricity production(% of total) in Myanmar?
Provide a short and direct response. -50.89. In the year 2006, what is the difference between the Electricity production(% of total) of Lebanon and Electricity production(% of total) of Myanmar?
Keep it short and to the point. -47.96. What is the ratio of the Electricity production(% of total) in East Asia (developing only) in 2000 to that in 2001?
Your response must be concise. 0.89. What is the ratio of the Electricity production(% of total) of Czech Republic in 2000 to that in 2001?
Your answer should be compact. 0.87. What is the ratio of the Electricity production(% of total) in Lebanon in 2000 to that in 2001?
Provide a short and direct response. 1.41. What is the ratio of the Electricity production(% of total) of Myanmar in 2000 to that in 2001?
Make the answer very short. 0.95. What is the ratio of the Electricity production(% of total) of East Asia (developing only) in 2000 to that in 2002?
Offer a very short reply. 0.96. What is the ratio of the Electricity production(% of total) in Czech Republic in 2000 to that in 2002?
Your answer should be very brief. 0.74. What is the ratio of the Electricity production(% of total) in Lebanon in 2000 to that in 2002?
Offer a terse response. 0.8. What is the ratio of the Electricity production(% of total) in Myanmar in 2000 to that in 2002?
Provide a short and direct response. 0.89. What is the ratio of the Electricity production(% of total) in East Asia (developing only) in 2000 to that in 2003?
Provide a succinct answer. 1.11. What is the ratio of the Electricity production(% of total) in Czech Republic in 2000 to that in 2003?
Your answer should be compact. 1.44. What is the ratio of the Electricity production(% of total) in Lebanon in 2000 to that in 2003?
Give a very brief answer. 0.43. What is the ratio of the Electricity production(% of total) of Myanmar in 2000 to that in 2003?
Your answer should be compact. 0.97. What is the ratio of the Electricity production(% of total) in East Asia (developing only) in 2000 to that in 2004?
Provide a succinct answer. 1.05. What is the ratio of the Electricity production(% of total) in Czech Republic in 2000 to that in 2004?
Your answer should be very brief. 1. What is the ratio of the Electricity production(% of total) of Lebanon in 2000 to that in 2004?
Offer a very short reply. 0.51. What is the ratio of the Electricity production(% of total) in Myanmar in 2000 to that in 2004?
Your answer should be very brief. 0.86. What is the ratio of the Electricity production(% of total) of East Asia (developing only) in 2000 to that in 2005?
Offer a very short reply. 1.06. What is the ratio of the Electricity production(% of total) of Czech Republic in 2000 to that in 2005?
Ensure brevity in your answer.  0.83. What is the ratio of the Electricity production(% of total) of Lebanon in 2000 to that in 2005?
Provide a succinct answer. 0.55. What is the ratio of the Electricity production(% of total) in Myanmar in 2000 to that in 2005?
Provide a succinct answer. 0.74. What is the ratio of the Electricity production(% of total) of East Asia (developing only) in 2000 to that in 2006?
Offer a terse response. 1.09. What is the ratio of the Electricity production(% of total) in Czech Republic in 2000 to that in 2006?
Make the answer very short. 0.79. What is the ratio of the Electricity production(% of total) in Lebanon in 2000 to that in 2006?
Offer a very short reply. 0.77. What is the ratio of the Electricity production(% of total) of Myanmar in 2000 to that in 2006?
Provide a short and direct response. 0.69. What is the ratio of the Electricity production(% of total) in East Asia (developing only) in 2001 to that in 2002?
Your answer should be very brief. 1.08. What is the ratio of the Electricity production(% of total) in Czech Republic in 2001 to that in 2002?
Offer a very short reply. 0.84. What is the ratio of the Electricity production(% of total) in Lebanon in 2001 to that in 2002?
Your answer should be very brief. 0.57. What is the ratio of the Electricity production(% of total) in Myanmar in 2001 to that in 2002?
Your answer should be very brief. 0.93. What is the ratio of the Electricity production(% of total) of East Asia (developing only) in 2001 to that in 2003?
Your answer should be compact. 1.24. What is the ratio of the Electricity production(% of total) of Czech Republic in 2001 to that in 2003?
Give a very brief answer. 1.66. What is the ratio of the Electricity production(% of total) of Lebanon in 2001 to that in 2003?
Your answer should be compact. 0.3. What is the ratio of the Electricity production(% of total) in Myanmar in 2001 to that in 2003?
Your answer should be very brief. 1.02. What is the ratio of the Electricity production(% of total) of East Asia (developing only) in 2001 to that in 2004?
Keep it short and to the point. 1.17. What is the ratio of the Electricity production(% of total) of Czech Republic in 2001 to that in 2004?
Your response must be concise. 1.15. What is the ratio of the Electricity production(% of total) of Lebanon in 2001 to that in 2004?
Provide a succinct answer. 0.36. What is the ratio of the Electricity production(% of total) of Myanmar in 2001 to that in 2004?
Your response must be concise. 0.91. What is the ratio of the Electricity production(% of total) of East Asia (developing only) in 2001 to that in 2005?
Provide a short and direct response. 1.19. What is the ratio of the Electricity production(% of total) in Czech Republic in 2001 to that in 2005?
Offer a very short reply. 0.95. What is the ratio of the Electricity production(% of total) of Lebanon in 2001 to that in 2005?
Give a very brief answer. 0.39. What is the ratio of the Electricity production(% of total) of Myanmar in 2001 to that in 2005?
Keep it short and to the point. 0.78. What is the ratio of the Electricity production(% of total) in East Asia (developing only) in 2001 to that in 2006?
Give a very brief answer. 1.22. What is the ratio of the Electricity production(% of total) of Czech Republic in 2001 to that in 2006?
Your response must be concise. 0.91. What is the ratio of the Electricity production(% of total) in Lebanon in 2001 to that in 2006?
Offer a terse response. 0.55. What is the ratio of the Electricity production(% of total) of Myanmar in 2001 to that in 2006?
Offer a terse response. 0.72. What is the ratio of the Electricity production(% of total) of East Asia (developing only) in 2002 to that in 2003?
Your answer should be very brief. 1.15. What is the ratio of the Electricity production(% of total) in Czech Republic in 2002 to that in 2003?
Offer a very short reply. 1.96. What is the ratio of the Electricity production(% of total) of Lebanon in 2002 to that in 2003?
Ensure brevity in your answer.  0.54. What is the ratio of the Electricity production(% of total) of Myanmar in 2002 to that in 2003?
Keep it short and to the point. 1.09. What is the ratio of the Electricity production(% of total) in East Asia (developing only) in 2002 to that in 2004?
Keep it short and to the point. 1.08. What is the ratio of the Electricity production(% of total) of Czech Republic in 2002 to that in 2004?
Your response must be concise. 1.36. What is the ratio of the Electricity production(% of total) in Lebanon in 2002 to that in 2004?
Ensure brevity in your answer.  0.64. What is the ratio of the Electricity production(% of total) of Myanmar in 2002 to that in 2004?
Ensure brevity in your answer.  0.97. What is the ratio of the Electricity production(% of total) in East Asia (developing only) in 2002 to that in 2005?
Your answer should be compact. 1.1. What is the ratio of the Electricity production(% of total) in Czech Republic in 2002 to that in 2005?
Your response must be concise. 1.13. What is the ratio of the Electricity production(% of total) in Lebanon in 2002 to that in 2005?
Your answer should be compact. 0.69. What is the ratio of the Electricity production(% of total) in Myanmar in 2002 to that in 2005?
Provide a short and direct response. 0.84. What is the ratio of the Electricity production(% of total) in East Asia (developing only) in 2002 to that in 2006?
Give a very brief answer. 1.13. What is the ratio of the Electricity production(% of total) of Czech Republic in 2002 to that in 2006?
Your response must be concise. 1.08. What is the ratio of the Electricity production(% of total) of Lebanon in 2002 to that in 2006?
Offer a very short reply. 0.97. What is the ratio of the Electricity production(% of total) of Myanmar in 2002 to that in 2006?
Offer a terse response. 0.77. What is the ratio of the Electricity production(% of total) of East Asia (developing only) in 2003 to that in 2004?
Your answer should be very brief. 0.94. What is the ratio of the Electricity production(% of total) of Czech Republic in 2003 to that in 2004?
Give a very brief answer. 0.69. What is the ratio of the Electricity production(% of total) in Lebanon in 2003 to that in 2004?
Your answer should be very brief. 1.2. What is the ratio of the Electricity production(% of total) in Myanmar in 2003 to that in 2004?
Keep it short and to the point. 0.89. What is the ratio of the Electricity production(% of total) of East Asia (developing only) in 2003 to that in 2005?
Offer a terse response. 0.96. What is the ratio of the Electricity production(% of total) in Czech Republic in 2003 to that in 2005?
Keep it short and to the point. 0.57. What is the ratio of the Electricity production(% of total) of Lebanon in 2003 to that in 2005?
Your answer should be compact. 1.28. What is the ratio of the Electricity production(% of total) in Myanmar in 2003 to that in 2005?
Give a very brief answer. 0.77. What is the ratio of the Electricity production(% of total) in Czech Republic in 2003 to that in 2006?
Provide a short and direct response. 0.55. What is the ratio of the Electricity production(% of total) of Lebanon in 2003 to that in 2006?
Offer a very short reply. 1.8. What is the ratio of the Electricity production(% of total) in Myanmar in 2003 to that in 2006?
Ensure brevity in your answer.  0.71. What is the ratio of the Electricity production(% of total) of Czech Republic in 2004 to that in 2005?
Provide a succinct answer. 0.83. What is the ratio of the Electricity production(% of total) of Lebanon in 2004 to that in 2005?
Your answer should be compact. 1.07. What is the ratio of the Electricity production(% of total) of Myanmar in 2004 to that in 2005?
Offer a very short reply. 0.86. What is the ratio of the Electricity production(% of total) of East Asia (developing only) in 2004 to that in 2006?
Your answer should be very brief. 1.04. What is the ratio of the Electricity production(% of total) of Czech Republic in 2004 to that in 2006?
Offer a terse response. 0.79. What is the ratio of the Electricity production(% of total) of Lebanon in 2004 to that in 2006?
Give a very brief answer. 1.5. What is the ratio of the Electricity production(% of total) of Myanmar in 2004 to that in 2006?
Your answer should be very brief. 0.8. What is the ratio of the Electricity production(% of total) in East Asia (developing only) in 2005 to that in 2006?
Provide a succinct answer. 1.03. What is the ratio of the Electricity production(% of total) of Czech Republic in 2005 to that in 2006?
Make the answer very short. 0.95. What is the ratio of the Electricity production(% of total) in Lebanon in 2005 to that in 2006?
Provide a short and direct response. 1.41. What is the ratio of the Electricity production(% of total) in Myanmar in 2005 to that in 2006?
Keep it short and to the point. 0.92. What is the difference between the highest and the second highest Electricity production(% of total) of East Asia (developing only)?
Give a very brief answer. 1.33. What is the difference between the highest and the second highest Electricity production(% of total) of Czech Republic?
Provide a short and direct response. 0.23. What is the difference between the highest and the second highest Electricity production(% of total) in Lebanon?
Offer a terse response. 1.78. What is the difference between the highest and the second highest Electricity production(% of total) of Myanmar?
Make the answer very short. 4.13. What is the difference between the highest and the lowest Electricity production(% of total) of East Asia (developing only)?
Your response must be concise. 3.51. What is the difference between the highest and the lowest Electricity production(% of total) of Czech Republic?
Offer a terse response. 1.61. What is the difference between the highest and the lowest Electricity production(% of total) of Lebanon?
Ensure brevity in your answer.  7.48. What is the difference between the highest and the lowest Electricity production(% of total) of Myanmar?
Keep it short and to the point. 16.97. 